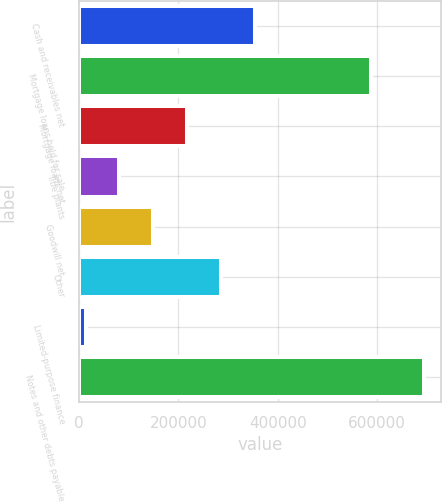<chart> <loc_0><loc_0><loc_500><loc_500><bar_chart><fcel>Cash and receivables net<fcel>Mortgage loans held for sale<fcel>Mortgage loans net<fcel>Title plants<fcel>Goodwill net<fcel>Other<fcel>Limited-purpose finance<fcel>Notes and other debts payable<nl><fcel>353538<fcel>587694<fcel>217382<fcel>81224.5<fcel>149303<fcel>285460<fcel>13146<fcel>693931<nl></chart> 